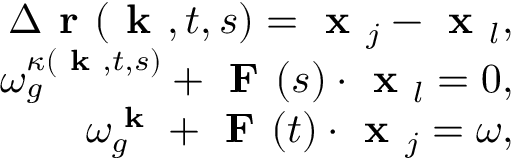<formula> <loc_0><loc_0><loc_500><loc_500>\begin{array} { r } { \Delta r ( k , t , s ) = x _ { j } - x _ { l } , } \\ { \omega _ { g } ^ { \kappa ( k , t , s ) } + F ( s ) \cdot x _ { l } = 0 , } \\ { \omega _ { g } ^ { k } + F ( t ) \cdot x _ { j } = \omega , } \end{array}</formula> 